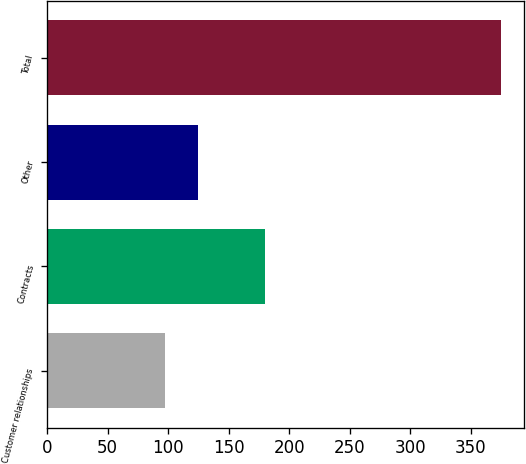Convert chart to OTSL. <chart><loc_0><loc_0><loc_500><loc_500><bar_chart><fcel>Customer relationships<fcel>Contracts<fcel>Other<fcel>Total<nl><fcel>97<fcel>180<fcel>124.8<fcel>375<nl></chart> 